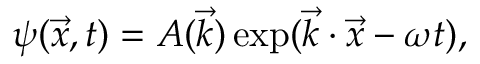<formula> <loc_0><loc_0><loc_500><loc_500>\psi ( \vec { x } , t ) = A ( \vec { k } ) \exp ( \vec { k } \cdot \vec { x } - \omega t ) ,</formula> 